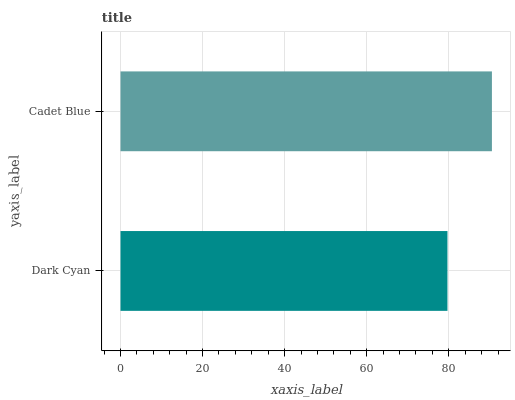Is Dark Cyan the minimum?
Answer yes or no. Yes. Is Cadet Blue the maximum?
Answer yes or no. Yes. Is Cadet Blue the minimum?
Answer yes or no. No. Is Cadet Blue greater than Dark Cyan?
Answer yes or no. Yes. Is Dark Cyan less than Cadet Blue?
Answer yes or no. Yes. Is Dark Cyan greater than Cadet Blue?
Answer yes or no. No. Is Cadet Blue less than Dark Cyan?
Answer yes or no. No. Is Cadet Blue the high median?
Answer yes or no. Yes. Is Dark Cyan the low median?
Answer yes or no. Yes. Is Dark Cyan the high median?
Answer yes or no. No. Is Cadet Blue the low median?
Answer yes or no. No. 